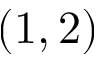Convert formula to latex. <formula><loc_0><loc_0><loc_500><loc_500>( 1 , 2 )</formula> 